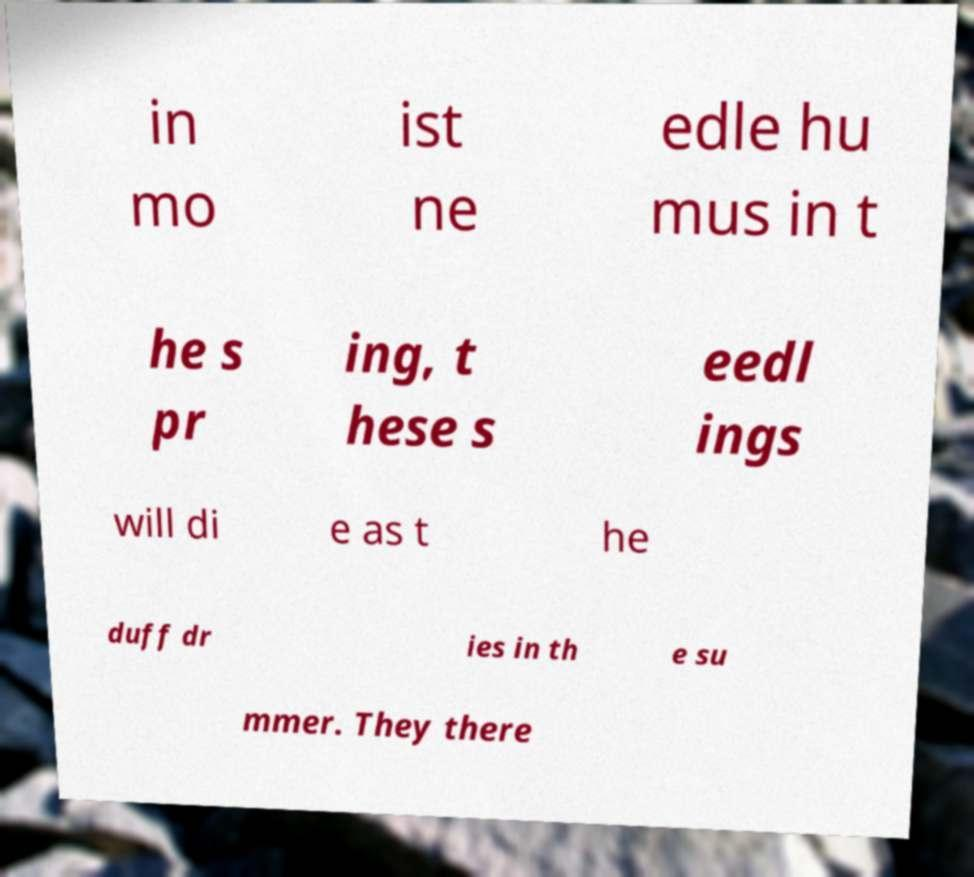Could you assist in decoding the text presented in this image and type it out clearly? in mo ist ne edle hu mus in t he s pr ing, t hese s eedl ings will di e as t he duff dr ies in th e su mmer. They there 